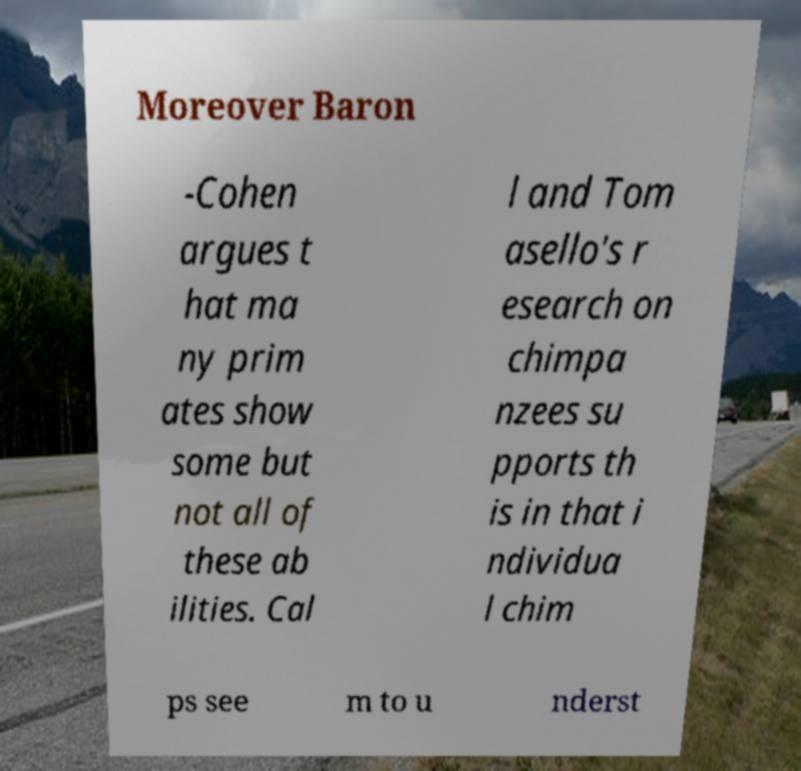Please read and relay the text visible in this image. What does it say? Moreover Baron -Cohen argues t hat ma ny prim ates show some but not all of these ab ilities. Cal l and Tom asello's r esearch on chimpa nzees su pports th is in that i ndividua l chim ps see m to u nderst 